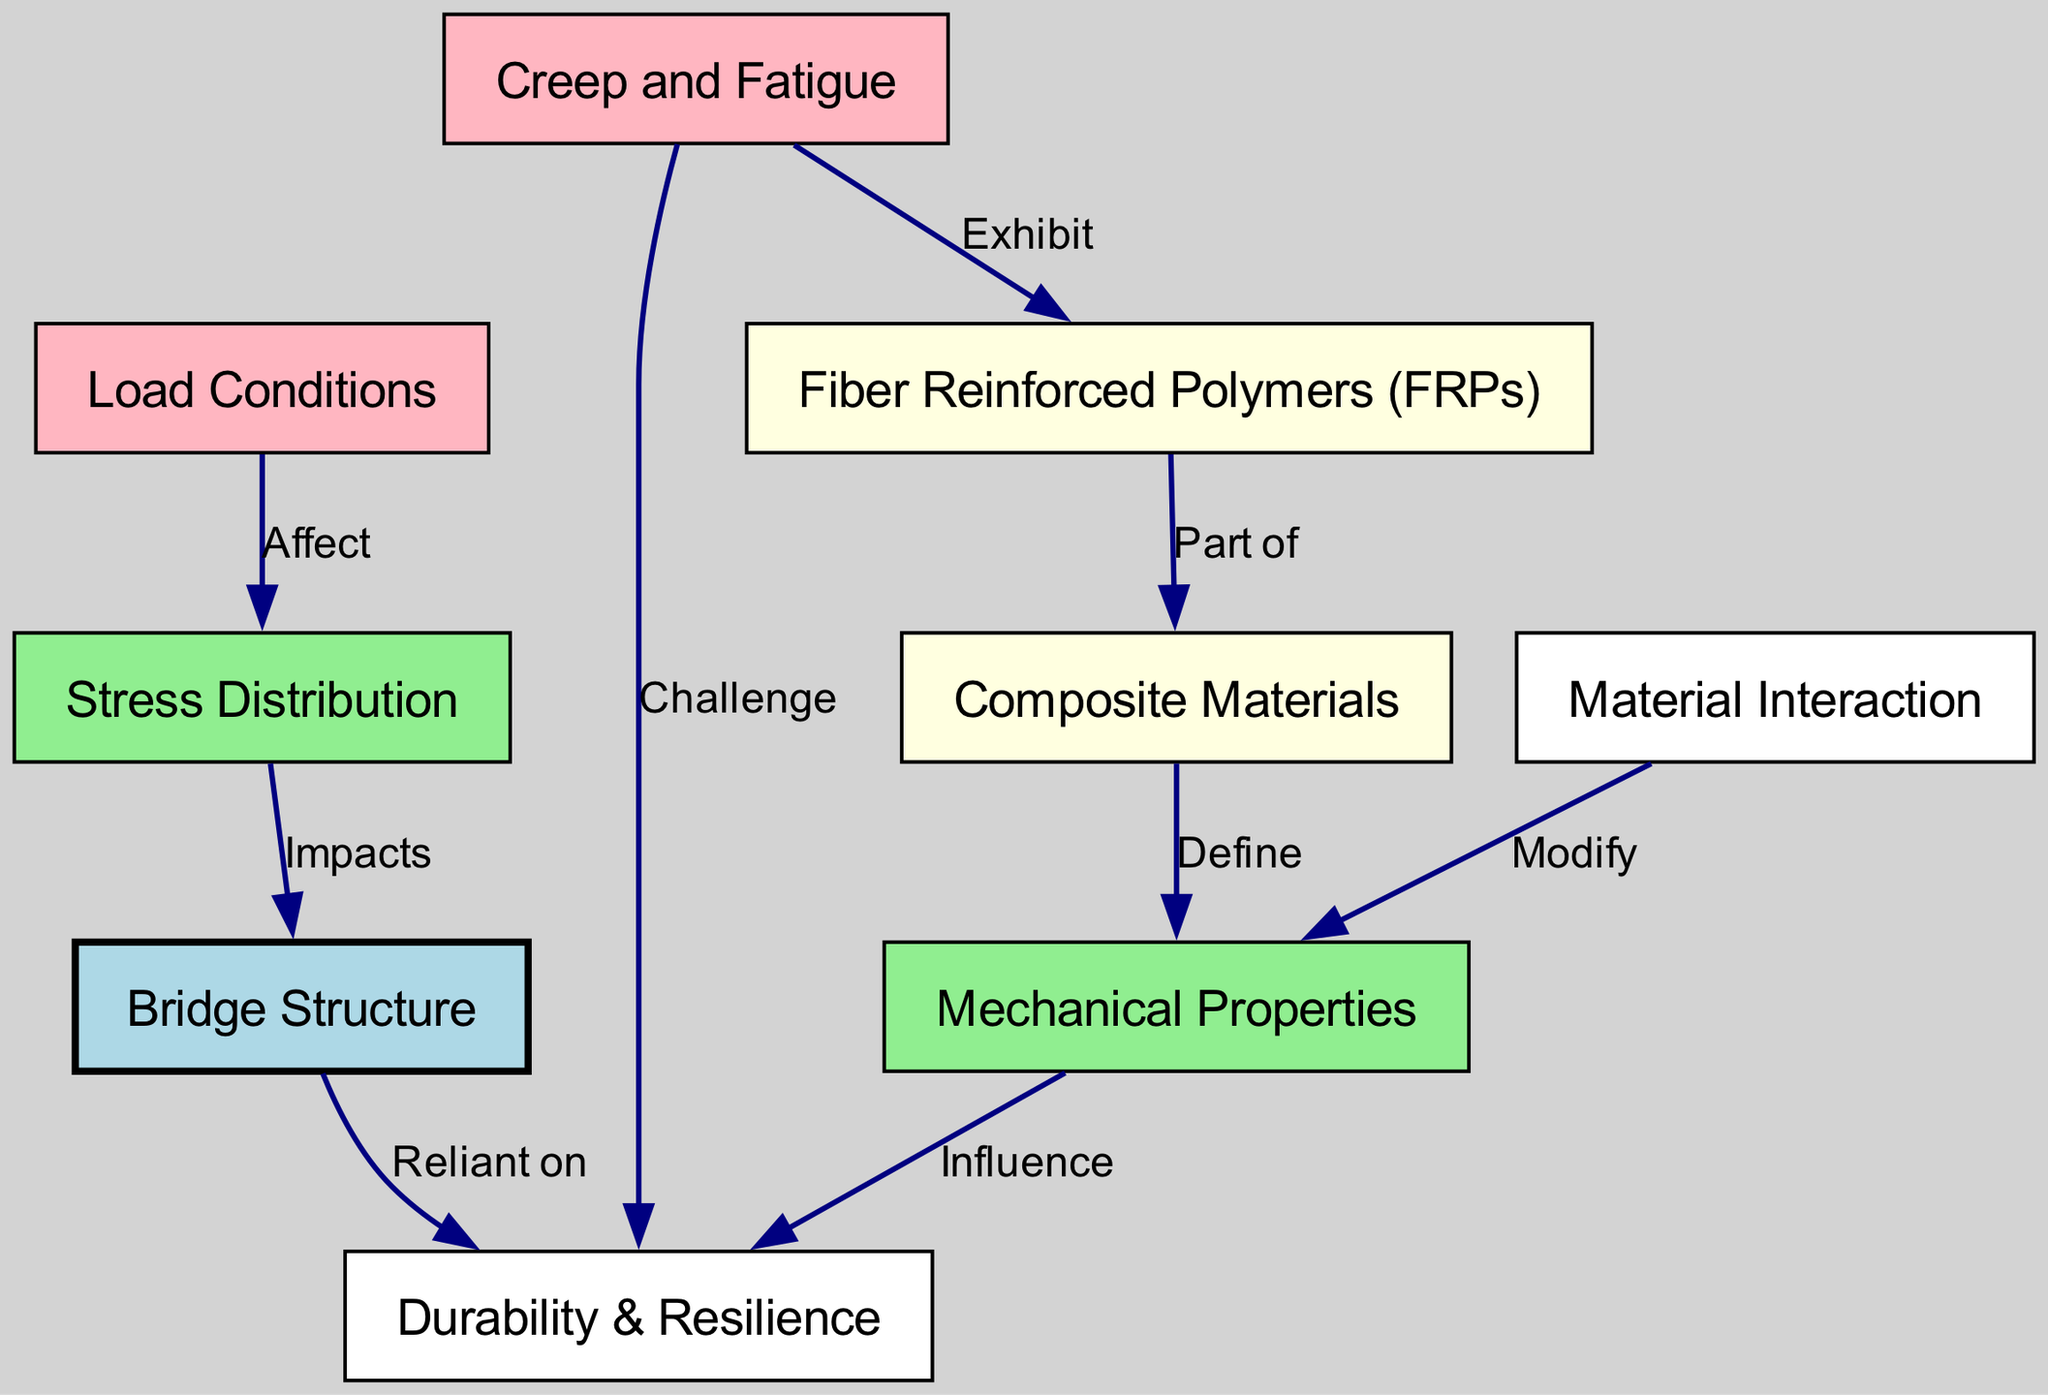What are the two types of materials mentioned in the diagram? The diagram highlights two types of materials: Composite Materials and Fiber Reinforced Polymers (FRPs). These are explicitly labeled as nodes in the diagram.
Answer: Composite Materials, Fiber Reinforced Polymers (FRPs) How many nodes are present in the diagram? By counting the nodes listed in the diagram, we find a total of nine distinct nodes related to material properties and bridge design.
Answer: 9 Which node is impacted by stress distribution? The diagram indicates that Stress Distribution impacts the Bridge Structure, as shown by the directed edge connecting these two nodes labeled "Impacts".
Answer: Bridge Structure What does mechanical properties influence according to the diagram? The diagram clearly shows that Mechanical Properties influence Durability & Resilience, indicated by a directed edge connecting these two nodes.
Answer: Durability & Resilience What challenges do creep and fatigue pose? The diagram states that creep and fatigue challenge Durability & Resilience, as indicated by the directed edge connecting these nodes labeled "Challenge".
Answer: Durability & Resilience Which node modifies mechanical properties? The diagram specifies that Material Interaction modifies Mechanical Properties through a directed edge labeled "Modify".
Answer: Material Interaction How do load conditions affect stress distribution? The diagram illustrates that Load Conditions affect Stress Distribution, which is shown by the edge labeled "Affect" connecting these two nodes.
Answer: Affect What is the color of the bridge structure node in the diagram? The color attributed to the Bridge Structure node in the diagram is light blue, making it visually distinct from other nodes.
Answer: Light Blue How many edges connect composite materials to mechanical properties? There is one edge in the diagram that connects Composite Materials to Mechanical Properties, indicating their relationship labeled "Define".
Answer: 1 